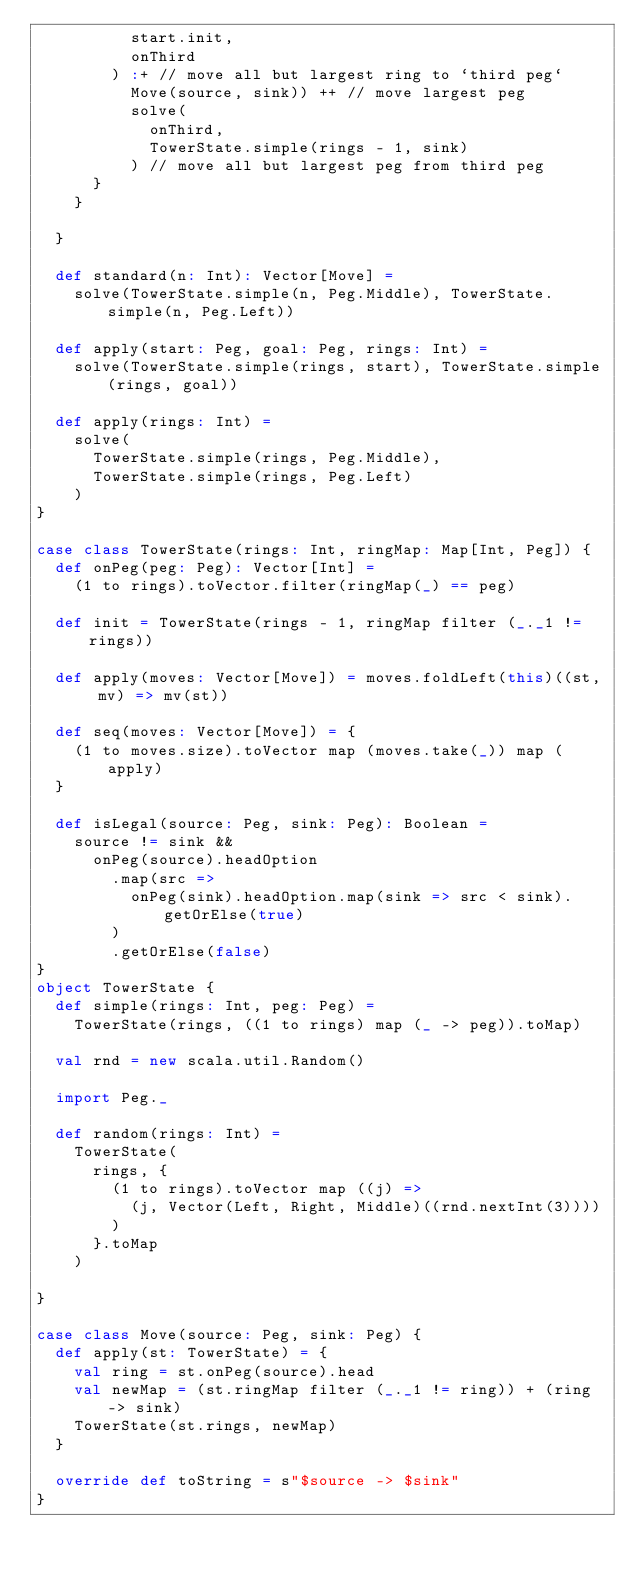Convert code to text. <code><loc_0><loc_0><loc_500><loc_500><_Scala_>          start.init,
          onThird
        ) :+ // move all but largest ring to `third peg`
          Move(source, sink)) ++ // move largest peg
          solve(
            onThird,
            TowerState.simple(rings - 1, sink)
          ) // move all but largest peg from third peg
      }
    }

  }

  def standard(n: Int): Vector[Move] =
    solve(TowerState.simple(n, Peg.Middle), TowerState.simple(n, Peg.Left))

  def apply(start: Peg, goal: Peg, rings: Int) =
    solve(TowerState.simple(rings, start), TowerState.simple(rings, goal))

  def apply(rings: Int) =
    solve(
      TowerState.simple(rings, Peg.Middle),
      TowerState.simple(rings, Peg.Left)
    )
}

case class TowerState(rings: Int, ringMap: Map[Int, Peg]) {
  def onPeg(peg: Peg): Vector[Int] =
    (1 to rings).toVector.filter(ringMap(_) == peg)

  def init = TowerState(rings - 1, ringMap filter (_._1 != rings))

  def apply(moves: Vector[Move]) = moves.foldLeft(this)((st, mv) => mv(st))

  def seq(moves: Vector[Move]) = {
    (1 to moves.size).toVector map (moves.take(_)) map (apply)
  }

  def isLegal(source: Peg, sink: Peg): Boolean =
    source != sink &&
      onPeg(source).headOption
        .map(src =>
          onPeg(sink).headOption.map(sink => src < sink).getOrElse(true)
        )
        .getOrElse(false)
}
object TowerState {
  def simple(rings: Int, peg: Peg) =
    TowerState(rings, ((1 to rings) map (_ -> peg)).toMap)

  val rnd = new scala.util.Random()

  import Peg._

  def random(rings: Int) =
    TowerState(
      rings, {
        (1 to rings).toVector map ((j) =>
          (j, Vector(Left, Right, Middle)((rnd.nextInt(3))))
        )
      }.toMap
    )

}

case class Move(source: Peg, sink: Peg) {
  def apply(st: TowerState) = {
    val ring = st.onPeg(source).head
    val newMap = (st.ringMap filter (_._1 != ring)) + (ring -> sink)
    TowerState(st.rings, newMap)
  }

  override def toString = s"$source -> $sink"
}
</code> 